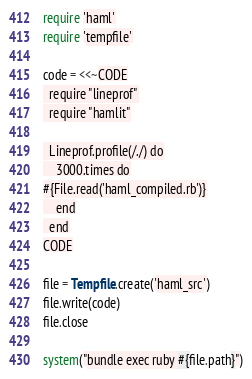<code> <loc_0><loc_0><loc_500><loc_500><_Ruby_>require 'haml'
require 'tempfile'

code = <<~CODE
  require "lineprof"
  require "hamlit"

  Lineprof.profile(/./) do
    3000.times do
#{File.read('haml_compiled.rb')}
    end
  end
CODE

file = Tempfile.create('haml_src')
file.write(code)
file.close

system("bundle exec ruby #{file.path}")
</code> 